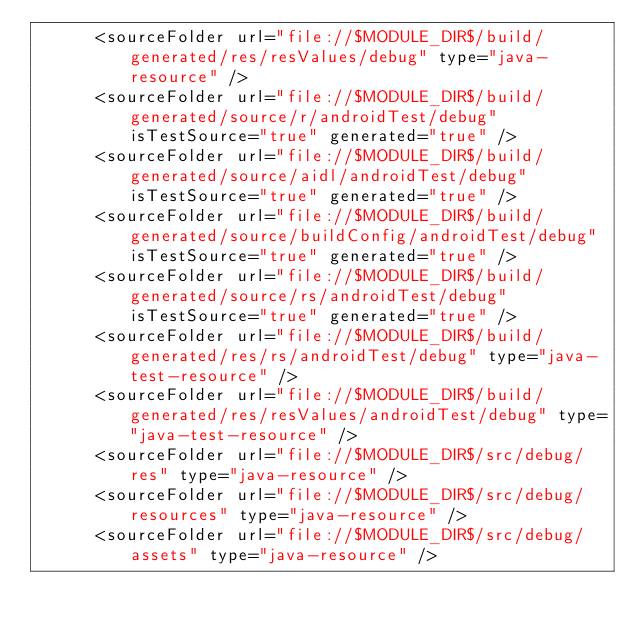Convert code to text. <code><loc_0><loc_0><loc_500><loc_500><_XML_>      <sourceFolder url="file://$MODULE_DIR$/build/generated/res/resValues/debug" type="java-resource" />
      <sourceFolder url="file://$MODULE_DIR$/build/generated/source/r/androidTest/debug" isTestSource="true" generated="true" />
      <sourceFolder url="file://$MODULE_DIR$/build/generated/source/aidl/androidTest/debug" isTestSource="true" generated="true" />
      <sourceFolder url="file://$MODULE_DIR$/build/generated/source/buildConfig/androidTest/debug" isTestSource="true" generated="true" />
      <sourceFolder url="file://$MODULE_DIR$/build/generated/source/rs/androidTest/debug" isTestSource="true" generated="true" />
      <sourceFolder url="file://$MODULE_DIR$/build/generated/res/rs/androidTest/debug" type="java-test-resource" />
      <sourceFolder url="file://$MODULE_DIR$/build/generated/res/resValues/androidTest/debug" type="java-test-resource" />
      <sourceFolder url="file://$MODULE_DIR$/src/debug/res" type="java-resource" />
      <sourceFolder url="file://$MODULE_DIR$/src/debug/resources" type="java-resource" />
      <sourceFolder url="file://$MODULE_DIR$/src/debug/assets" type="java-resource" /></code> 